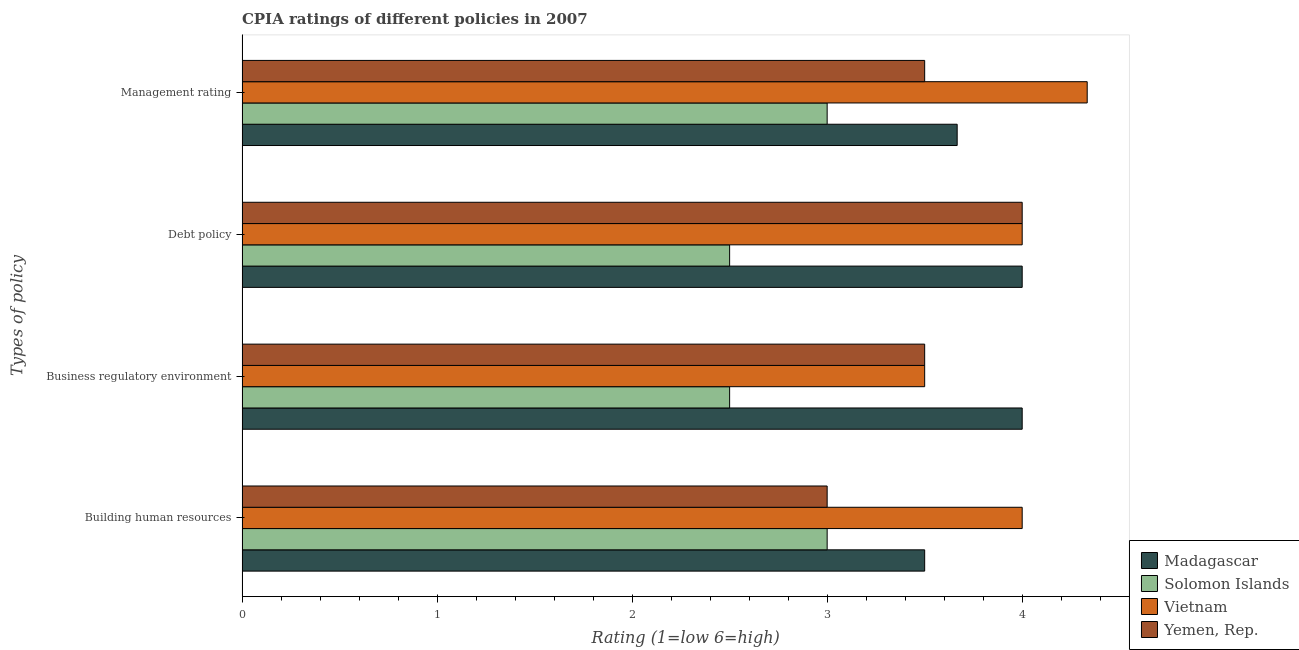How many groups of bars are there?
Provide a short and direct response. 4. Are the number of bars per tick equal to the number of legend labels?
Ensure brevity in your answer.  Yes. Are the number of bars on each tick of the Y-axis equal?
Provide a succinct answer. Yes. How many bars are there on the 2nd tick from the bottom?
Ensure brevity in your answer.  4. What is the label of the 3rd group of bars from the top?
Provide a succinct answer. Business regulatory environment. What is the cpia rating of management in Madagascar?
Your answer should be very brief. 3.67. Across all countries, what is the minimum cpia rating of debt policy?
Offer a very short reply. 2.5. In which country was the cpia rating of building human resources maximum?
Keep it short and to the point. Vietnam. In which country was the cpia rating of building human resources minimum?
Ensure brevity in your answer.  Solomon Islands. What is the difference between the cpia rating of debt policy in Vietnam and that in Yemen, Rep.?
Keep it short and to the point. 0. What is the difference between the cpia rating of debt policy in Madagascar and the cpia rating of business regulatory environment in Solomon Islands?
Keep it short and to the point. 1.5. What is the average cpia rating of building human resources per country?
Give a very brief answer. 3.38. What is the difference between the cpia rating of management and cpia rating of debt policy in Yemen, Rep.?
Make the answer very short. -0.5. What is the ratio of the cpia rating of business regulatory environment in Solomon Islands to that in Vietnam?
Your answer should be very brief. 0.71. Is the difference between the cpia rating of debt policy in Solomon Islands and Vietnam greater than the difference between the cpia rating of management in Solomon Islands and Vietnam?
Make the answer very short. No. What is the difference between the highest and the second highest cpia rating of management?
Offer a very short reply. 0.67. What is the difference between the highest and the lowest cpia rating of debt policy?
Your answer should be compact. 1.5. What does the 2nd bar from the top in Debt policy represents?
Make the answer very short. Vietnam. What does the 4th bar from the bottom in Business regulatory environment represents?
Provide a short and direct response. Yemen, Rep. How many bars are there?
Keep it short and to the point. 16. Are all the bars in the graph horizontal?
Ensure brevity in your answer.  Yes. How many countries are there in the graph?
Offer a terse response. 4. Does the graph contain grids?
Offer a very short reply. No. Where does the legend appear in the graph?
Offer a very short reply. Bottom right. How many legend labels are there?
Keep it short and to the point. 4. What is the title of the graph?
Give a very brief answer. CPIA ratings of different policies in 2007. Does "Samoa" appear as one of the legend labels in the graph?
Ensure brevity in your answer.  No. What is the label or title of the Y-axis?
Your answer should be compact. Types of policy. What is the Rating (1=low 6=high) of Madagascar in Building human resources?
Make the answer very short. 3.5. What is the Rating (1=low 6=high) in Solomon Islands in Building human resources?
Make the answer very short. 3. What is the Rating (1=low 6=high) in Yemen, Rep. in Building human resources?
Your answer should be compact. 3. What is the Rating (1=low 6=high) of Madagascar in Business regulatory environment?
Provide a succinct answer. 4. What is the Rating (1=low 6=high) of Solomon Islands in Business regulatory environment?
Keep it short and to the point. 2.5. What is the Rating (1=low 6=high) in Madagascar in Debt policy?
Provide a short and direct response. 4. What is the Rating (1=low 6=high) in Madagascar in Management rating?
Offer a terse response. 3.67. What is the Rating (1=low 6=high) in Solomon Islands in Management rating?
Make the answer very short. 3. What is the Rating (1=low 6=high) of Vietnam in Management rating?
Provide a succinct answer. 4.33. Across all Types of policy, what is the maximum Rating (1=low 6=high) of Madagascar?
Make the answer very short. 4. Across all Types of policy, what is the maximum Rating (1=low 6=high) of Solomon Islands?
Offer a terse response. 3. Across all Types of policy, what is the maximum Rating (1=low 6=high) of Vietnam?
Provide a succinct answer. 4.33. Across all Types of policy, what is the maximum Rating (1=low 6=high) of Yemen, Rep.?
Ensure brevity in your answer.  4. Across all Types of policy, what is the minimum Rating (1=low 6=high) in Yemen, Rep.?
Give a very brief answer. 3. What is the total Rating (1=low 6=high) of Madagascar in the graph?
Offer a very short reply. 15.17. What is the total Rating (1=low 6=high) of Vietnam in the graph?
Provide a short and direct response. 15.83. What is the total Rating (1=low 6=high) of Yemen, Rep. in the graph?
Give a very brief answer. 14. What is the difference between the Rating (1=low 6=high) in Madagascar in Building human resources and that in Business regulatory environment?
Give a very brief answer. -0.5. What is the difference between the Rating (1=low 6=high) in Solomon Islands in Building human resources and that in Business regulatory environment?
Your response must be concise. 0.5. What is the difference between the Rating (1=low 6=high) of Yemen, Rep. in Building human resources and that in Business regulatory environment?
Ensure brevity in your answer.  -0.5. What is the difference between the Rating (1=low 6=high) in Solomon Islands in Building human resources and that in Debt policy?
Offer a very short reply. 0.5. What is the difference between the Rating (1=low 6=high) of Vietnam in Building human resources and that in Debt policy?
Provide a short and direct response. 0. What is the difference between the Rating (1=low 6=high) of Yemen, Rep. in Building human resources and that in Debt policy?
Provide a succinct answer. -1. What is the difference between the Rating (1=low 6=high) in Madagascar in Building human resources and that in Management rating?
Ensure brevity in your answer.  -0.17. What is the difference between the Rating (1=low 6=high) in Solomon Islands in Building human resources and that in Management rating?
Offer a very short reply. 0. What is the difference between the Rating (1=low 6=high) in Yemen, Rep. in Building human resources and that in Management rating?
Your answer should be compact. -0.5. What is the difference between the Rating (1=low 6=high) of Yemen, Rep. in Business regulatory environment and that in Debt policy?
Your response must be concise. -0.5. What is the difference between the Rating (1=low 6=high) in Madagascar in Business regulatory environment and that in Management rating?
Offer a very short reply. 0.33. What is the difference between the Rating (1=low 6=high) of Yemen, Rep. in Business regulatory environment and that in Management rating?
Provide a succinct answer. 0. What is the difference between the Rating (1=low 6=high) of Madagascar in Debt policy and that in Management rating?
Offer a terse response. 0.33. What is the difference between the Rating (1=low 6=high) in Solomon Islands in Debt policy and that in Management rating?
Your response must be concise. -0.5. What is the difference between the Rating (1=low 6=high) in Vietnam in Debt policy and that in Management rating?
Offer a terse response. -0.33. What is the difference between the Rating (1=low 6=high) in Madagascar in Building human resources and the Rating (1=low 6=high) in Solomon Islands in Business regulatory environment?
Provide a succinct answer. 1. What is the difference between the Rating (1=low 6=high) in Madagascar in Building human resources and the Rating (1=low 6=high) in Vietnam in Business regulatory environment?
Keep it short and to the point. 0. What is the difference between the Rating (1=low 6=high) in Solomon Islands in Building human resources and the Rating (1=low 6=high) in Yemen, Rep. in Business regulatory environment?
Your answer should be compact. -0.5. What is the difference between the Rating (1=low 6=high) in Madagascar in Building human resources and the Rating (1=low 6=high) in Vietnam in Debt policy?
Your answer should be very brief. -0.5. What is the difference between the Rating (1=low 6=high) in Madagascar in Building human resources and the Rating (1=low 6=high) in Yemen, Rep. in Debt policy?
Provide a short and direct response. -0.5. What is the difference between the Rating (1=low 6=high) in Solomon Islands in Building human resources and the Rating (1=low 6=high) in Yemen, Rep. in Debt policy?
Your answer should be compact. -1. What is the difference between the Rating (1=low 6=high) of Vietnam in Building human resources and the Rating (1=low 6=high) of Yemen, Rep. in Debt policy?
Make the answer very short. 0. What is the difference between the Rating (1=low 6=high) of Madagascar in Building human resources and the Rating (1=low 6=high) of Solomon Islands in Management rating?
Provide a succinct answer. 0.5. What is the difference between the Rating (1=low 6=high) of Madagascar in Building human resources and the Rating (1=low 6=high) of Yemen, Rep. in Management rating?
Give a very brief answer. 0. What is the difference between the Rating (1=low 6=high) of Solomon Islands in Building human resources and the Rating (1=low 6=high) of Vietnam in Management rating?
Make the answer very short. -1.33. What is the difference between the Rating (1=low 6=high) of Vietnam in Building human resources and the Rating (1=low 6=high) of Yemen, Rep. in Management rating?
Your response must be concise. 0.5. What is the difference between the Rating (1=low 6=high) of Madagascar in Business regulatory environment and the Rating (1=low 6=high) of Solomon Islands in Debt policy?
Provide a short and direct response. 1.5. What is the difference between the Rating (1=low 6=high) of Solomon Islands in Business regulatory environment and the Rating (1=low 6=high) of Vietnam in Debt policy?
Provide a short and direct response. -1.5. What is the difference between the Rating (1=low 6=high) in Solomon Islands in Business regulatory environment and the Rating (1=low 6=high) in Yemen, Rep. in Debt policy?
Offer a very short reply. -1.5. What is the difference between the Rating (1=low 6=high) of Vietnam in Business regulatory environment and the Rating (1=low 6=high) of Yemen, Rep. in Debt policy?
Your answer should be very brief. -0.5. What is the difference between the Rating (1=low 6=high) of Madagascar in Business regulatory environment and the Rating (1=low 6=high) of Vietnam in Management rating?
Ensure brevity in your answer.  -0.33. What is the difference between the Rating (1=low 6=high) of Solomon Islands in Business regulatory environment and the Rating (1=low 6=high) of Vietnam in Management rating?
Ensure brevity in your answer.  -1.83. What is the difference between the Rating (1=low 6=high) in Vietnam in Business regulatory environment and the Rating (1=low 6=high) in Yemen, Rep. in Management rating?
Offer a terse response. 0. What is the difference between the Rating (1=low 6=high) in Madagascar in Debt policy and the Rating (1=low 6=high) in Solomon Islands in Management rating?
Provide a succinct answer. 1. What is the difference between the Rating (1=low 6=high) of Madagascar in Debt policy and the Rating (1=low 6=high) of Vietnam in Management rating?
Ensure brevity in your answer.  -0.33. What is the difference between the Rating (1=low 6=high) of Madagascar in Debt policy and the Rating (1=low 6=high) of Yemen, Rep. in Management rating?
Offer a very short reply. 0.5. What is the difference between the Rating (1=low 6=high) in Solomon Islands in Debt policy and the Rating (1=low 6=high) in Vietnam in Management rating?
Your answer should be compact. -1.83. What is the difference between the Rating (1=low 6=high) of Solomon Islands in Debt policy and the Rating (1=low 6=high) of Yemen, Rep. in Management rating?
Provide a succinct answer. -1. What is the difference between the Rating (1=low 6=high) of Vietnam in Debt policy and the Rating (1=low 6=high) of Yemen, Rep. in Management rating?
Give a very brief answer. 0.5. What is the average Rating (1=low 6=high) of Madagascar per Types of policy?
Offer a terse response. 3.79. What is the average Rating (1=low 6=high) of Solomon Islands per Types of policy?
Your answer should be very brief. 2.75. What is the average Rating (1=low 6=high) of Vietnam per Types of policy?
Give a very brief answer. 3.96. What is the difference between the Rating (1=low 6=high) in Madagascar and Rating (1=low 6=high) in Solomon Islands in Building human resources?
Make the answer very short. 0.5. What is the difference between the Rating (1=low 6=high) in Madagascar and Rating (1=low 6=high) in Vietnam in Building human resources?
Your response must be concise. -0.5. What is the difference between the Rating (1=low 6=high) of Solomon Islands and Rating (1=low 6=high) of Yemen, Rep. in Building human resources?
Give a very brief answer. 0. What is the difference between the Rating (1=low 6=high) of Madagascar and Rating (1=low 6=high) of Yemen, Rep. in Business regulatory environment?
Keep it short and to the point. 0.5. What is the difference between the Rating (1=low 6=high) of Solomon Islands and Rating (1=low 6=high) of Yemen, Rep. in Business regulatory environment?
Your answer should be compact. -1. What is the difference between the Rating (1=low 6=high) in Madagascar and Rating (1=low 6=high) in Vietnam in Debt policy?
Make the answer very short. 0. What is the difference between the Rating (1=low 6=high) in Madagascar and Rating (1=low 6=high) in Yemen, Rep. in Debt policy?
Ensure brevity in your answer.  0. What is the difference between the Rating (1=low 6=high) of Madagascar and Rating (1=low 6=high) of Solomon Islands in Management rating?
Your response must be concise. 0.67. What is the difference between the Rating (1=low 6=high) in Madagascar and Rating (1=low 6=high) in Vietnam in Management rating?
Offer a very short reply. -0.67. What is the difference between the Rating (1=low 6=high) in Madagascar and Rating (1=low 6=high) in Yemen, Rep. in Management rating?
Keep it short and to the point. 0.17. What is the difference between the Rating (1=low 6=high) of Solomon Islands and Rating (1=low 6=high) of Vietnam in Management rating?
Provide a short and direct response. -1.33. What is the ratio of the Rating (1=low 6=high) in Madagascar in Building human resources to that in Business regulatory environment?
Your answer should be compact. 0.88. What is the ratio of the Rating (1=low 6=high) of Solomon Islands in Building human resources to that in Business regulatory environment?
Ensure brevity in your answer.  1.2. What is the ratio of the Rating (1=low 6=high) in Vietnam in Building human resources to that in Business regulatory environment?
Provide a short and direct response. 1.14. What is the ratio of the Rating (1=low 6=high) of Yemen, Rep. in Building human resources to that in Business regulatory environment?
Provide a succinct answer. 0.86. What is the ratio of the Rating (1=low 6=high) in Madagascar in Building human resources to that in Debt policy?
Your answer should be very brief. 0.88. What is the ratio of the Rating (1=low 6=high) of Vietnam in Building human resources to that in Debt policy?
Offer a very short reply. 1. What is the ratio of the Rating (1=low 6=high) of Yemen, Rep. in Building human resources to that in Debt policy?
Offer a terse response. 0.75. What is the ratio of the Rating (1=low 6=high) of Madagascar in Building human resources to that in Management rating?
Offer a terse response. 0.95. What is the ratio of the Rating (1=low 6=high) in Vietnam in Building human resources to that in Management rating?
Ensure brevity in your answer.  0.92. What is the ratio of the Rating (1=low 6=high) of Yemen, Rep. in Building human resources to that in Management rating?
Provide a succinct answer. 0.86. What is the ratio of the Rating (1=low 6=high) in Yemen, Rep. in Business regulatory environment to that in Debt policy?
Give a very brief answer. 0.88. What is the ratio of the Rating (1=low 6=high) in Vietnam in Business regulatory environment to that in Management rating?
Make the answer very short. 0.81. What is the ratio of the Rating (1=low 6=high) in Yemen, Rep. in Business regulatory environment to that in Management rating?
Give a very brief answer. 1. What is the difference between the highest and the second highest Rating (1=low 6=high) of Madagascar?
Provide a succinct answer. 0. What is the difference between the highest and the second highest Rating (1=low 6=high) of Solomon Islands?
Your response must be concise. 0. What is the difference between the highest and the second highest Rating (1=low 6=high) in Vietnam?
Offer a very short reply. 0.33. What is the difference between the highest and the second highest Rating (1=low 6=high) in Yemen, Rep.?
Keep it short and to the point. 0.5. What is the difference between the highest and the lowest Rating (1=low 6=high) in Solomon Islands?
Ensure brevity in your answer.  0.5. What is the difference between the highest and the lowest Rating (1=low 6=high) of Yemen, Rep.?
Your answer should be very brief. 1. 